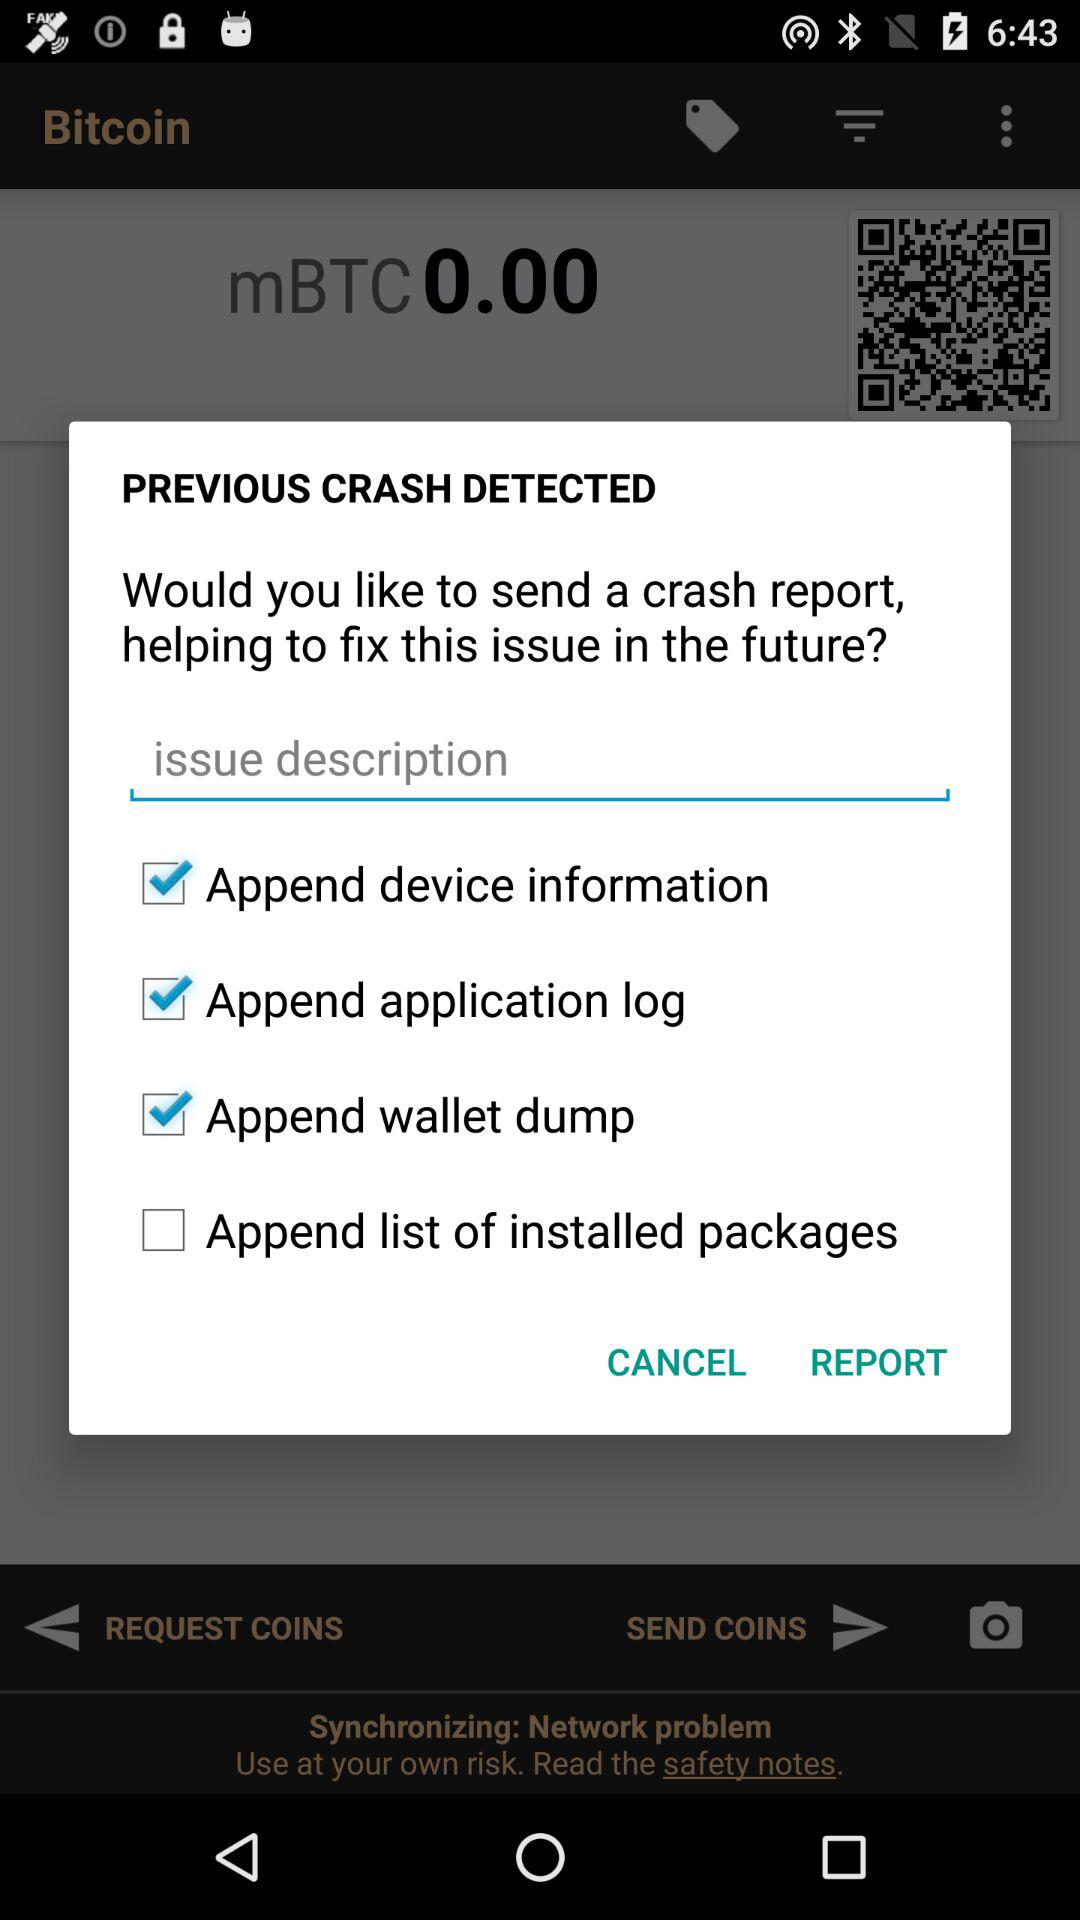Which issue is selected? The selected issues are : "Append device information", "Append application log", "Append wallet dump", and "Append list of installed packages". 